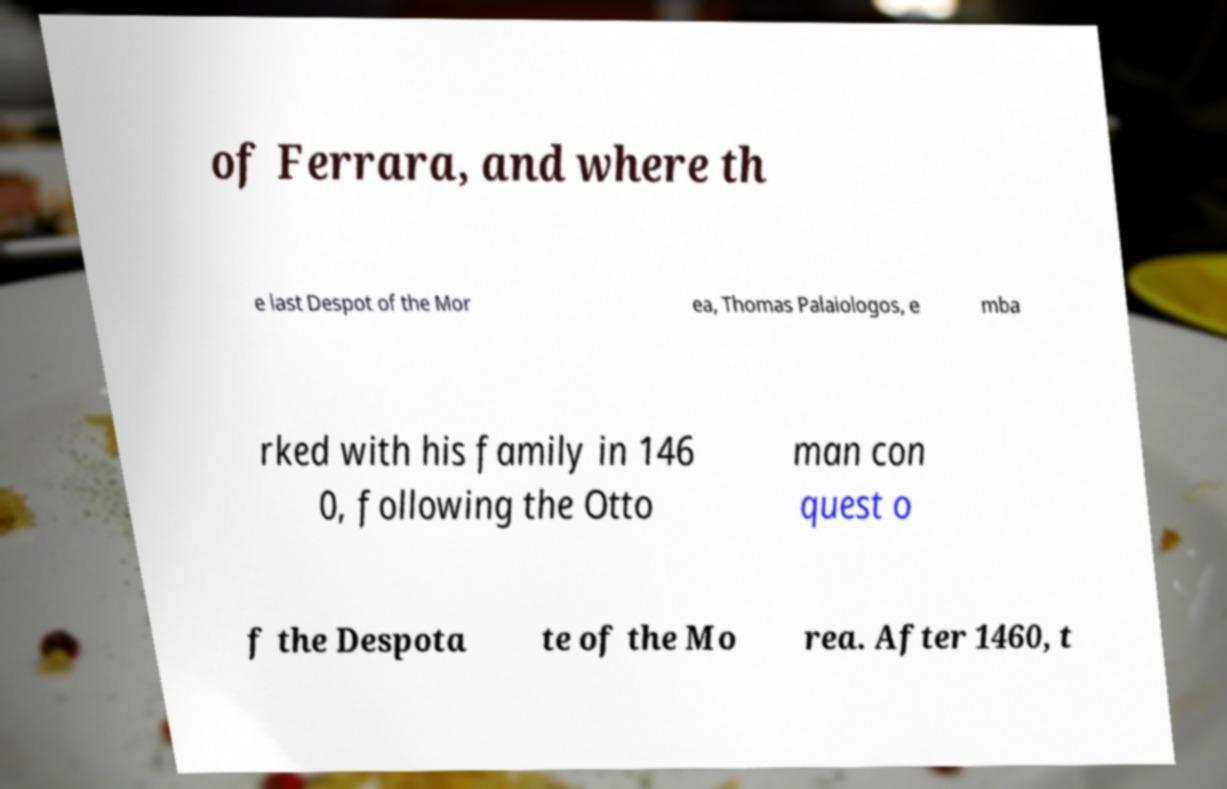Can you accurately transcribe the text from the provided image for me? of Ferrara, and where th e last Despot of the Mor ea, Thomas Palaiologos, e mba rked with his family in 146 0, following the Otto man con quest o f the Despota te of the Mo rea. After 1460, t 